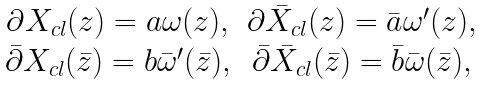Convert formula to latex. <formula><loc_0><loc_0><loc_500><loc_500>\begin{array} { c c } \partial X _ { c l } ( z ) = a \omega ( z ) , & \partial \bar { X } _ { c l } ( z ) = \bar { a } \omega ^ { \prime } ( z ) , \\ \bar { \partial } X _ { c l } ( \bar { z } ) = b \bar { \omega } ^ { \prime } ( \bar { z } ) , & \bar { \partial } \bar { X } _ { c l } ( \bar { z } ) = \bar { b } \bar { \omega } ( \bar { z } ) , \end{array}</formula> 